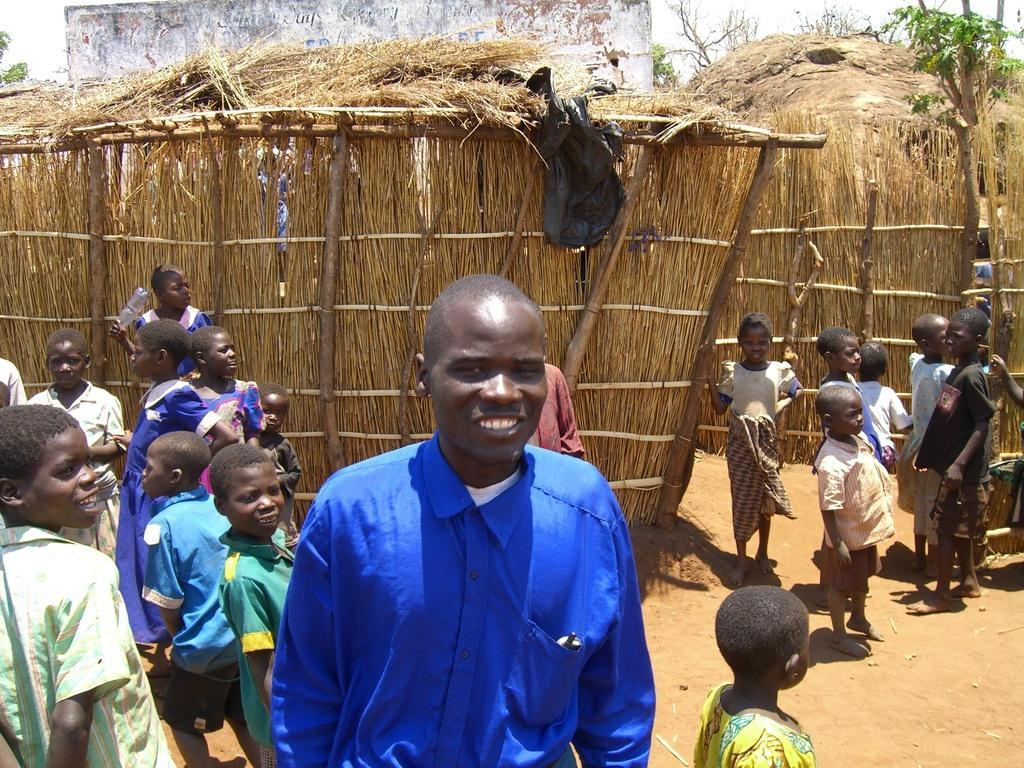How many people are in the image? There is a group of people in the image. Where are the people standing? The people are standing on a path. What can be seen in the image besides the people? There are wooden poles visible in the image. What is visible in the background of the image? There is a wall and the sky visible in the background of the image. What type of boot is being used to coil the rope in the image? There is no rope or boot present in the image; it features a group of people standing on a path with wooden poles and a wall in the background. 